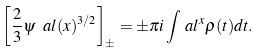Convert formula to latex. <formula><loc_0><loc_0><loc_500><loc_500>\left [ \frac { 2 } { 3 } \psi _ { \ } a l ( x ) ^ { 3 / 2 } \right ] _ { \pm } = \pm \pi i \int _ { \ } a l ^ { x } \rho ( t ) d t .</formula> 